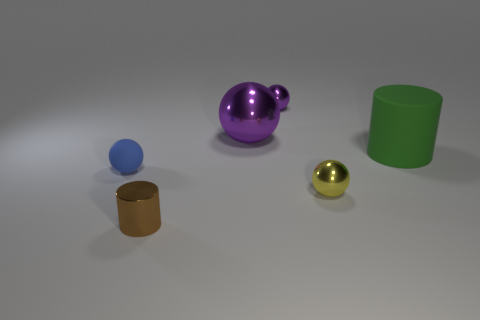There is a cylinder that is behind the shiny thing in front of the yellow thing; what is its size?
Your answer should be very brief. Large. How many big green things have the same shape as the brown metal object?
Your response must be concise. 1. Do the large metal ball and the large cylinder have the same color?
Provide a succinct answer. No. Is there any other thing that has the same shape as the green matte thing?
Offer a very short reply. Yes. Is there a small shiny sphere of the same color as the big metal sphere?
Your answer should be compact. Yes. Are the ball that is behind the big purple shiny ball and the large object that is in front of the big purple shiny object made of the same material?
Offer a terse response. No. What color is the large rubber thing?
Your answer should be compact. Green. There is a shiny sphere in front of the blue rubber object that is behind the shiny thing that is on the right side of the small purple metallic ball; how big is it?
Your answer should be compact. Small. What number of other things are there of the same size as the brown thing?
Keep it short and to the point. 3. What number of other objects are made of the same material as the brown thing?
Offer a very short reply. 3. 